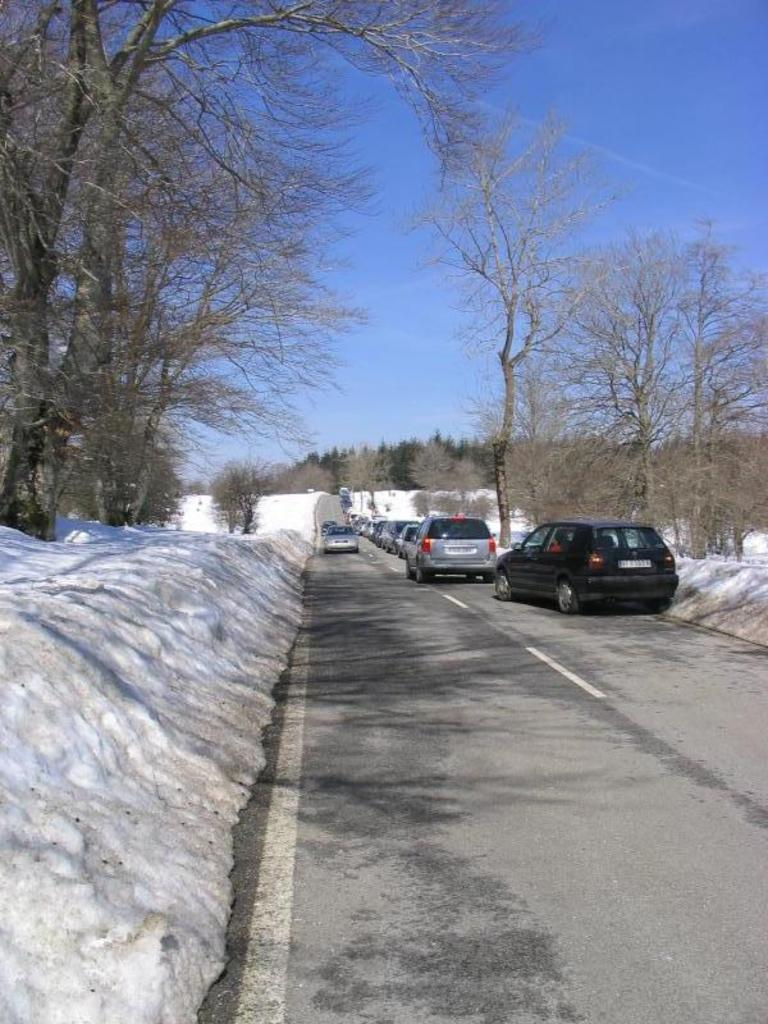What can be seen on the road in the image? There are vehicles on the road in the image. What is the condition of the ground in the image? Snow is present on the ground. What type of vegetation is visible in the image? Trees, bushes, and plants are present in the image. What is the natural ground cover in the image? Grass is on the ground. What is visible at the top of the image? The sky is visible at the top of the image. How many nails are used to hold the plantation in place in the image? There is no plantation present in the image, and therefore no nails are used to hold it in place. What type of knot is tied around the tree in the image? There is no knot tied around any tree in the image. 